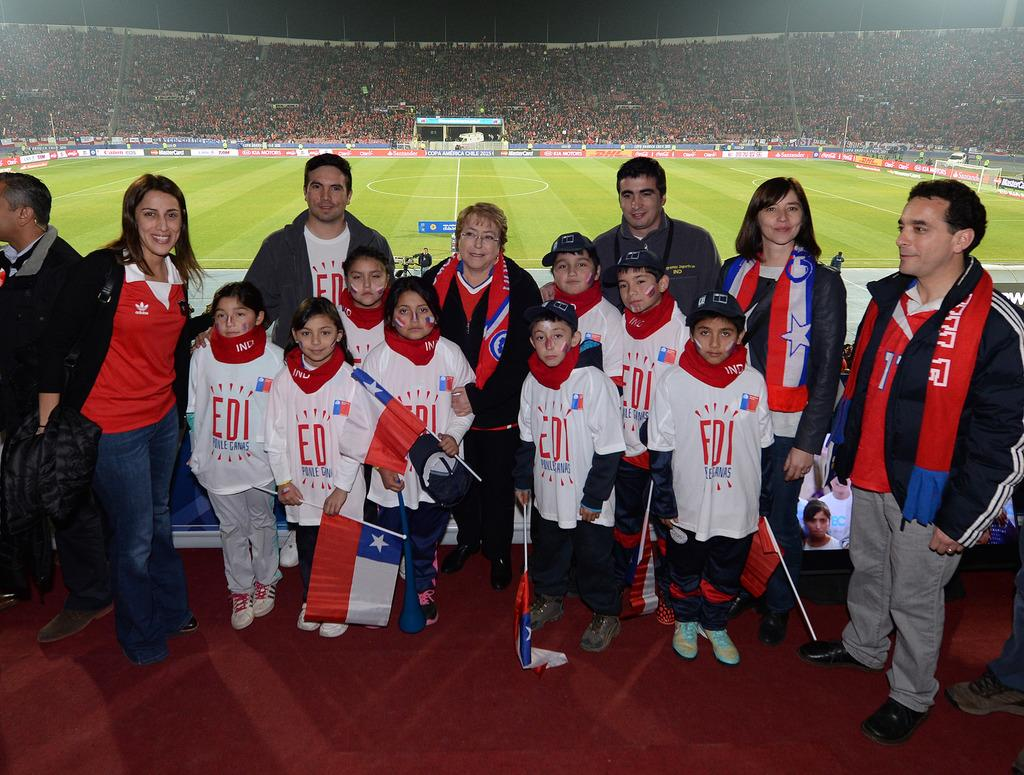<image>
Relay a brief, clear account of the picture shown. some kids with FDI shirts on their backs 